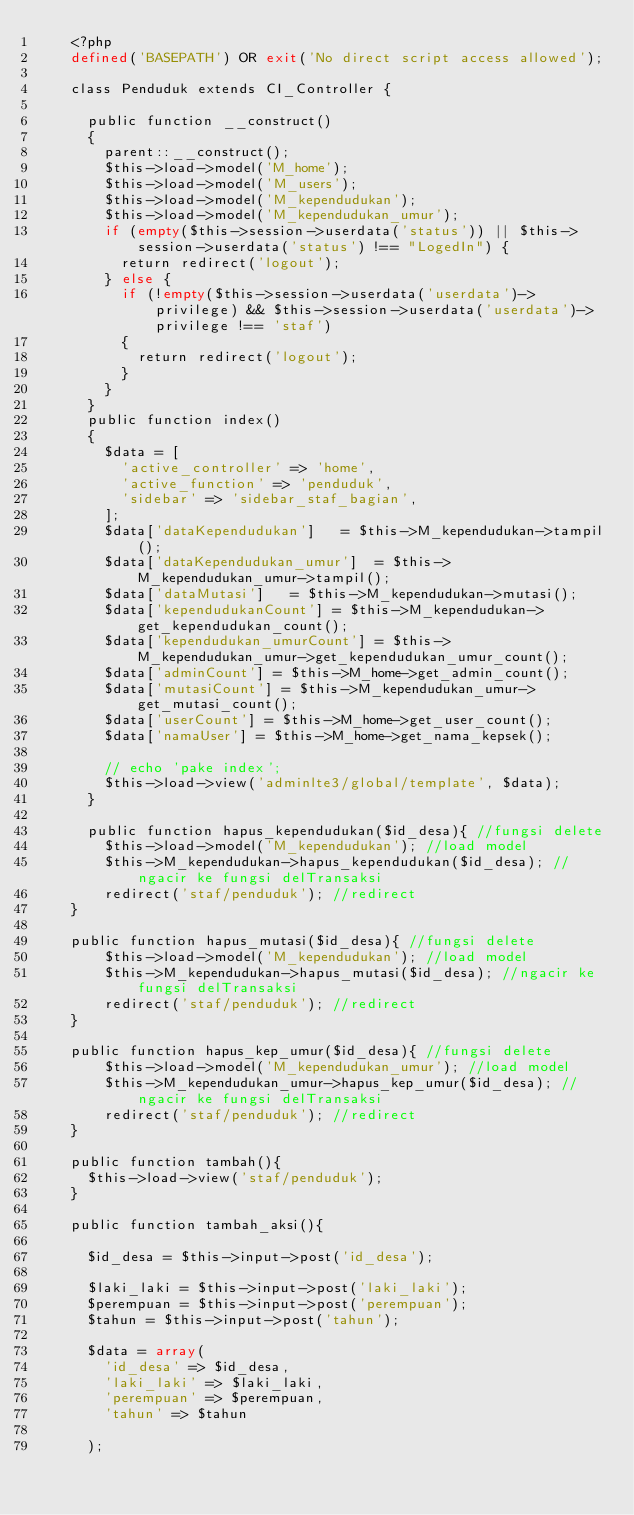Convert code to text. <code><loc_0><loc_0><loc_500><loc_500><_PHP_>		<?php
		defined('BASEPATH') OR exit('No direct script access allowed');

		class Penduduk extends CI_Controller {

			public function __construct() 
			{
				parent::__construct();
				$this->load->model('M_home');
				$this->load->model('M_users');
				$this->load->model('M_kependudukan');
				$this->load->model('M_kependudukan_umur');
				if (empty($this->session->userdata('status')) || $this->session->userdata('status') !== "LogedIn") {
					return redirect('logout');
				} else {
					if (!empty($this->session->userdata('userdata')->privilege) && $this->session->userdata('userdata')->privilege !== 'staf') 
					{
						return redirect('logout');		
					}
				}
			}
			public function index()
			{
				$data = [
					'active_controller' => 'home',
					'active_function' => 'penduduk',
					'sidebar' => 'sidebar_staf_bagian',
				];
				$data['dataKependudukan'] 	= $this->M_kependudukan->tampil();
				$data['dataKependudukan_umur'] 	= $this->M_kependudukan_umur->tampil();
				$data['dataMutasi'] 	= $this->M_kependudukan->mutasi();
				$data['kependudukanCount'] = $this->M_kependudukan->get_kependudukan_count();
				$data['kependudukan_umurCount'] = $this->M_kependudukan_umur->get_kependudukan_umur_count();
				$data['adminCount'] = $this->M_home->get_admin_count();
				$data['mutasiCount'] = $this->M_kependudukan_umur->get_mutasi_count();
				$data['userCount'] = $this->M_home->get_user_count();
				$data['namaUser'] = $this->M_home->get_nama_kepsek();

				// echo 'pake index';
				$this->load->view('adminlte3/global/template', $data);
			}	

			public function hapus_kependudukan($id_desa){ //fungsi delete
		    $this->load->model('M_kependudukan'); //load model
		    $this->M_kependudukan->hapus_kependudukan($id_desa); //ngacir ke fungsi delTransaksi
		    redirect('staf/penduduk'); //redirect
		}

		public function hapus_mutasi($id_desa){ //fungsi delete
		    $this->load->model('M_kependudukan'); //load model
		    $this->M_kependudukan->hapus_mutasi($id_desa); //ngacir ke fungsi delTransaksi
		    redirect('staf/penduduk'); //redirect
		}

		public function hapus_kep_umur($id_desa){ //fungsi delete
		    $this->load->model('M_kependudukan_umur'); //load model
		    $this->M_kependudukan_umur->hapus_kep_umur($id_desa); //ngacir ke fungsi delTransaksi
		    redirect('staf/penduduk'); //redirect
		}

		public function tambah(){
			$this->load->view('staf/penduduk');
		}

		public function tambah_aksi(){

			$id_desa = $this->input->post('id_desa');

			$laki_laki = $this->input->post('laki_laki');
			$perempuan = $this->input->post('perempuan');
			$tahun = $this->input->post('tahun');

			$data = array(
				'id_desa' => $id_desa,
				'laki_laki' => $laki_laki,
				'perempuan' => $perempuan,
				'tahun' => $tahun
				
			);</code> 